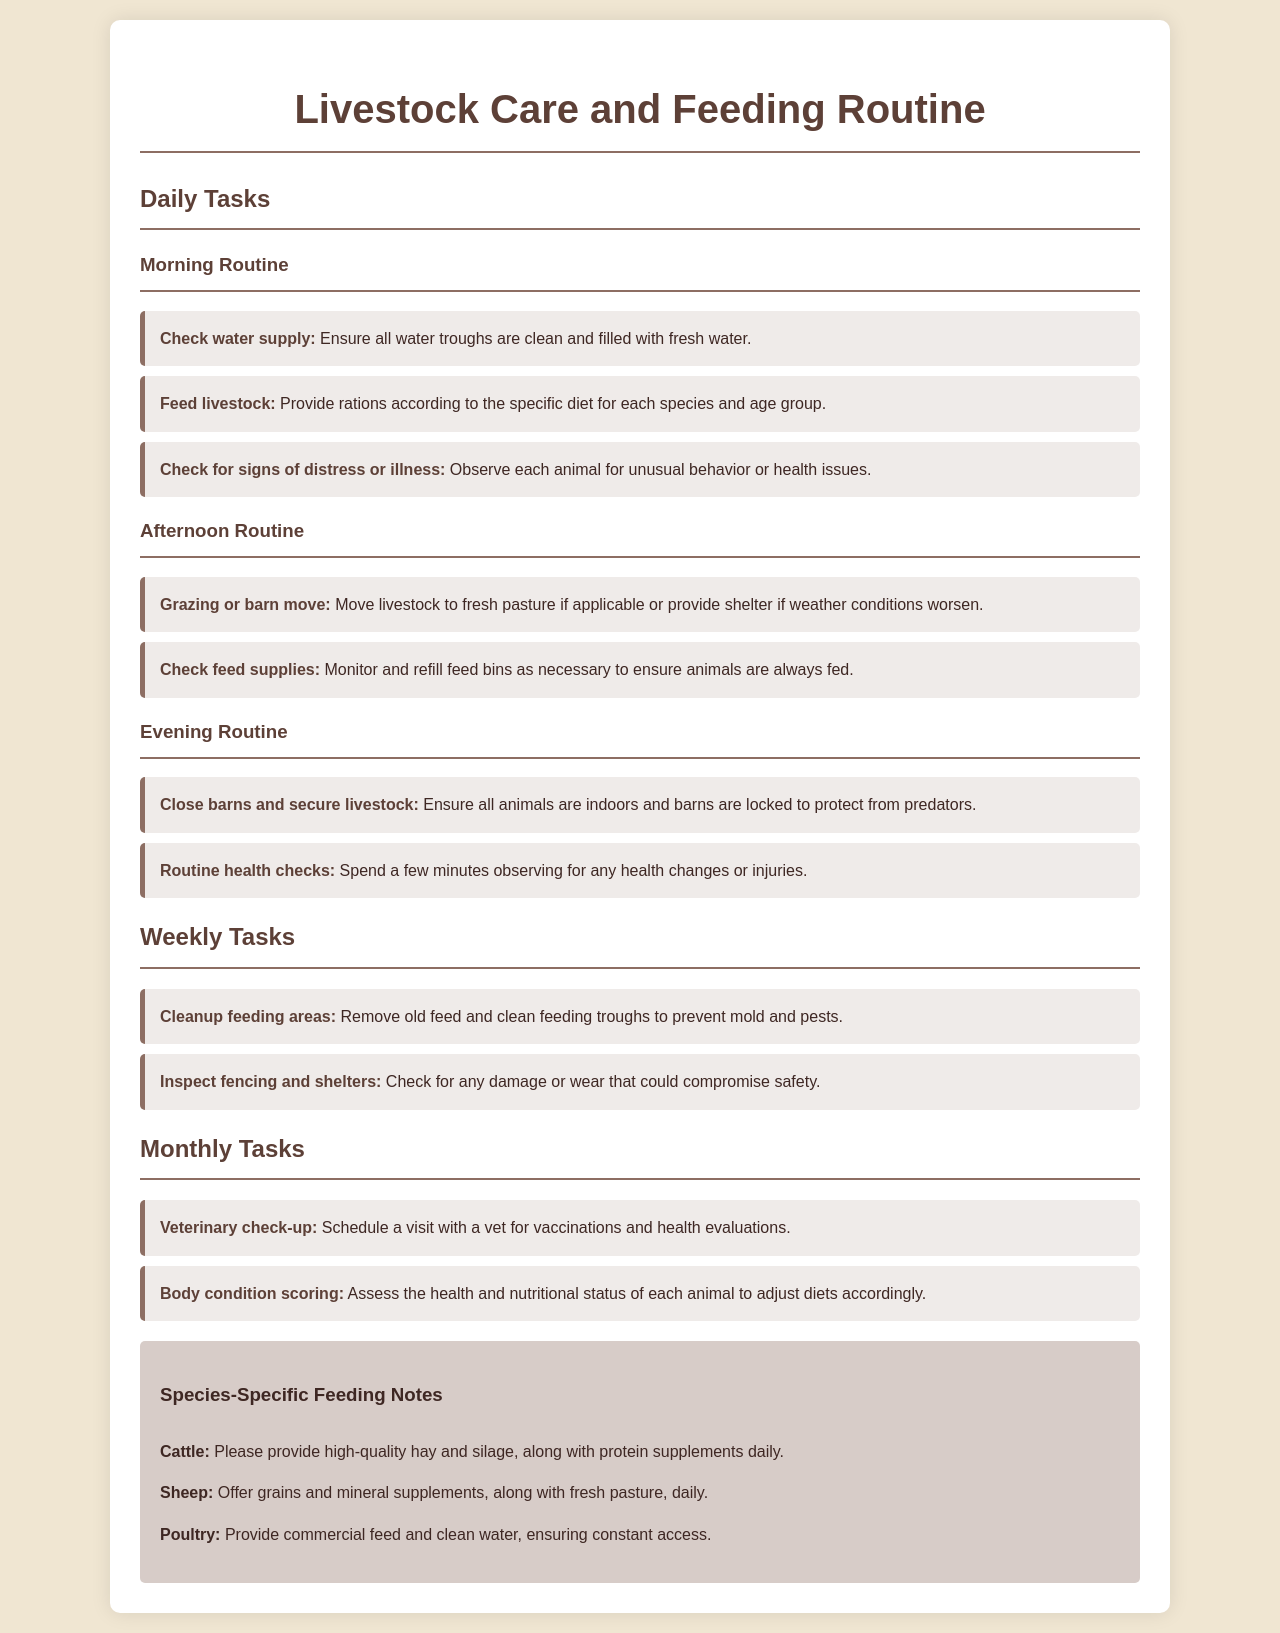What is the first task in the morning routine? The first task is to check the water supply.
Answer: Check water supply How often should veterinary check-ups be scheduled? Veterinary check-ups are listed as a monthly task.
Answer: Monthly What type of feed do poultry require? The document specifies that poultry should have access to commercial feed.
Answer: Commercial feed What are the specific feeding notes for sheep? The notes state that sheep should have grains and mineral supplements, along with fresh pasture.
Answer: Grains and mineral supplements, fresh pasture What routine task is outlined for afternoons? The afternoon task includes checking feed supplies.
Answer: Check feed supplies How many total daily tasks are listed in the document? There are three tasks in the morning, two in the afternoon, and two in the evening, which sums up to seven daily tasks.
Answer: Seven Which livestock should receive protein supplements? Cattle are specified to receive protein supplements.
Answer: Cattle 